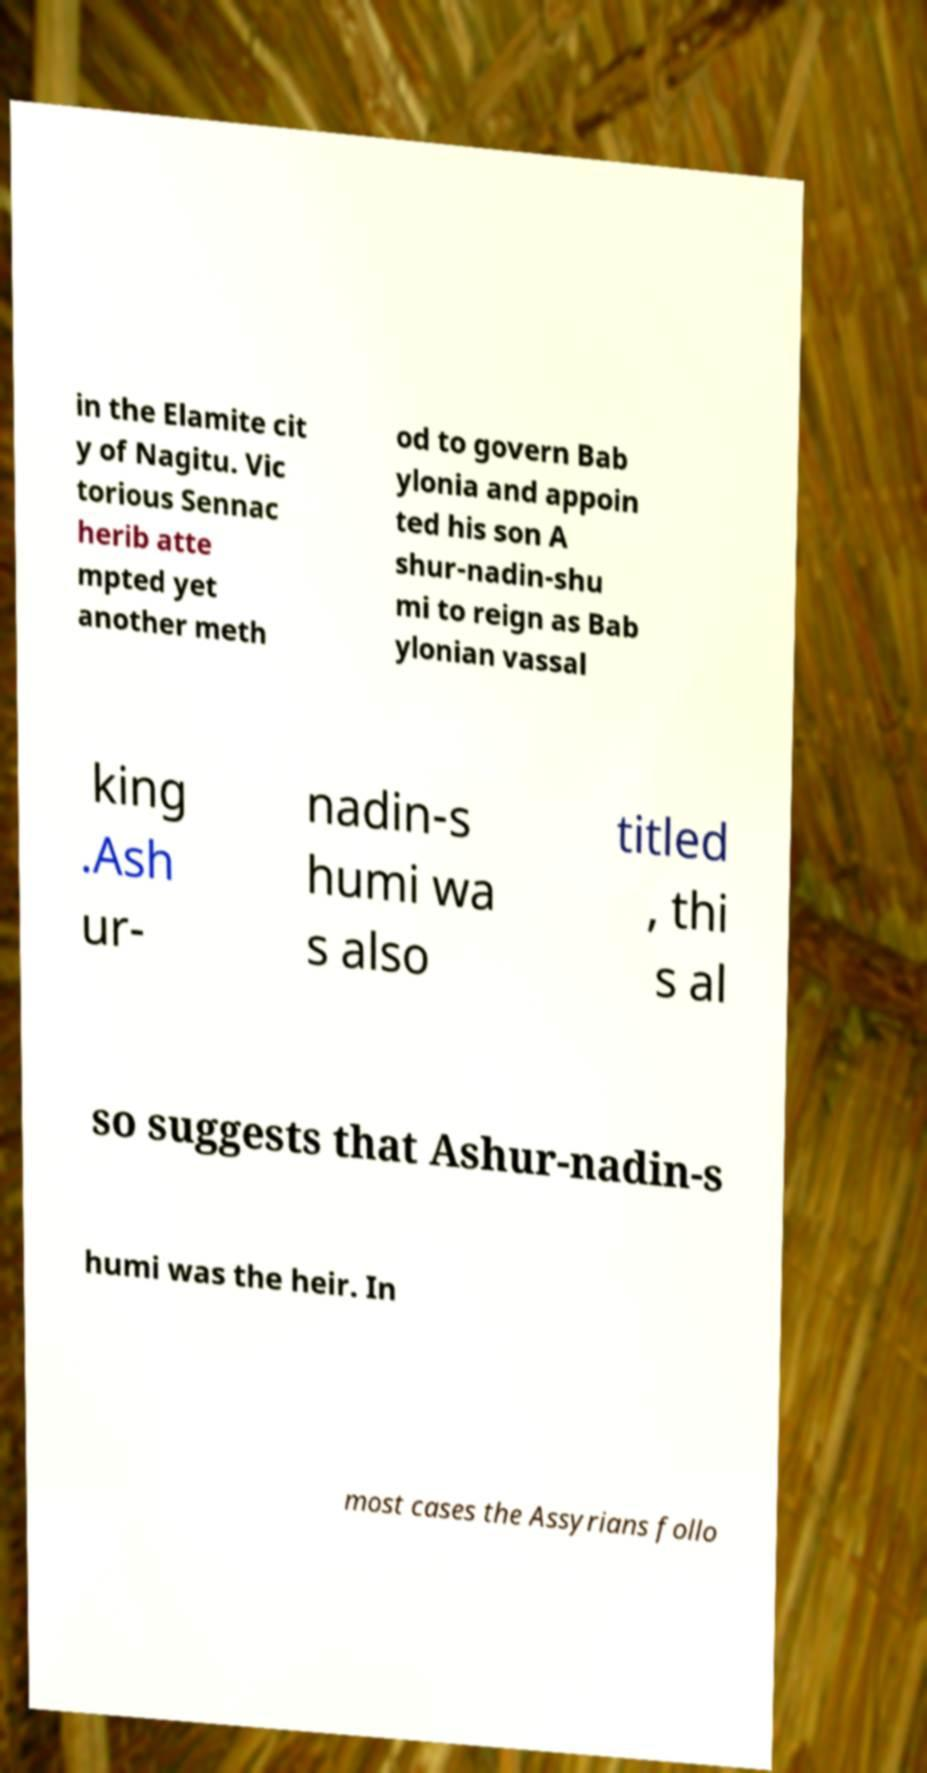What messages or text are displayed in this image? I need them in a readable, typed format. in the Elamite cit y of Nagitu. Vic torious Sennac herib atte mpted yet another meth od to govern Bab ylonia and appoin ted his son A shur-nadin-shu mi to reign as Bab ylonian vassal king .Ash ur- nadin-s humi wa s also titled , thi s al so suggests that Ashur-nadin-s humi was the heir. In most cases the Assyrians follo 